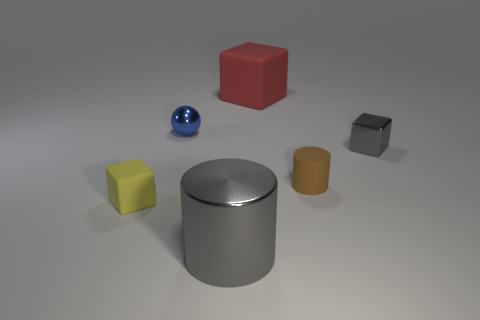The metallic thing that is the same color as the big cylinder is what size?
Ensure brevity in your answer.  Small. Is there any other thing of the same color as the large cube?
Make the answer very short. No. How many other objects are there of the same size as the metallic cube?
Provide a short and direct response. 3. There is a big thing that is behind the cylinder to the right of the gray metallic thing on the left side of the gray cube; what is it made of?
Your answer should be compact. Rubber. Is the material of the large gray cylinder the same as the tiny cube in front of the gray block?
Your response must be concise. No. Is the number of tiny yellow things that are behind the blue shiny thing less than the number of small blue spheres behind the tiny gray thing?
Offer a very short reply. Yes. How many big green balls are made of the same material as the large block?
Make the answer very short. 0. There is a small thing that is behind the gray shiny thing that is behind the yellow cube; is there a tiny cube right of it?
Your answer should be compact. Yes. How many cylinders are big blue shiny things or tiny gray metallic things?
Make the answer very short. 0. There is a yellow rubber thing; does it have the same shape as the gray thing that is right of the big matte object?
Provide a succinct answer. Yes. 